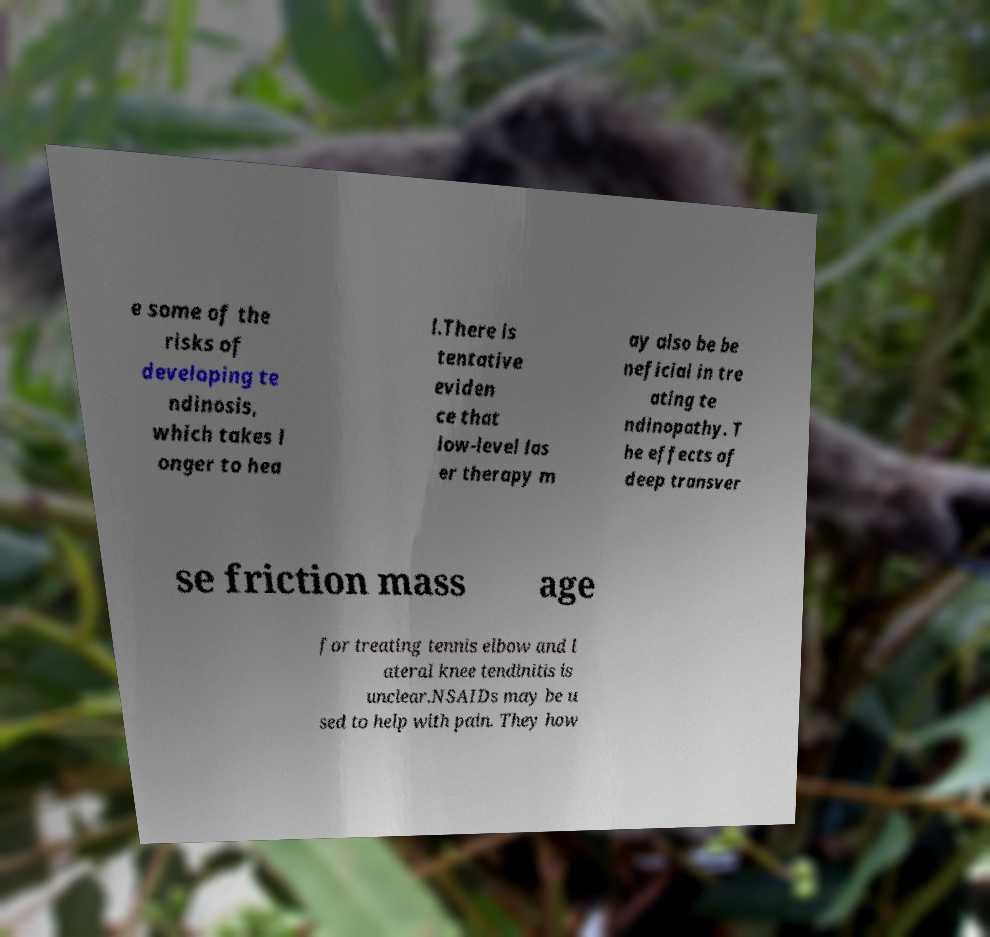Could you assist in decoding the text presented in this image and type it out clearly? e some of the risks of developing te ndinosis, which takes l onger to hea l.There is tentative eviden ce that low-level las er therapy m ay also be be neficial in tre ating te ndinopathy. T he effects of deep transver se friction mass age for treating tennis elbow and l ateral knee tendinitis is unclear.NSAIDs may be u sed to help with pain. They how 